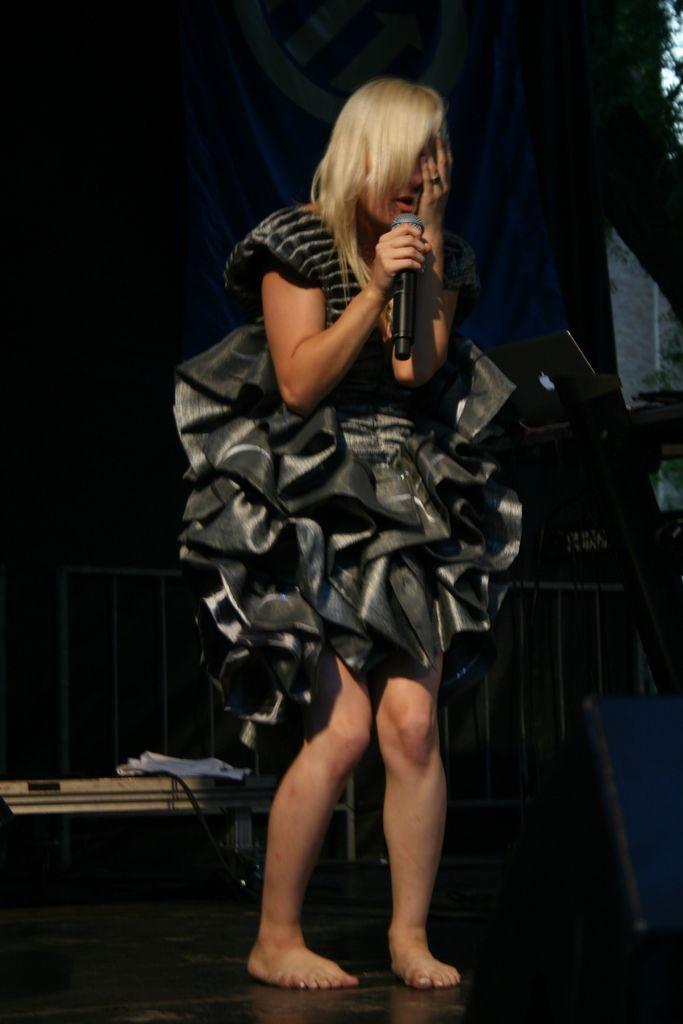Can you describe this image briefly? In this picture you can a lady. She is wearing a black frock. And she is holding mic in her right hand. At the back of her there is blue color flag. And to the left of her there is a laptop. 